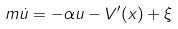Convert formula to latex. <formula><loc_0><loc_0><loc_500><loc_500>m \dot { u } = - \alpha u - V ^ { \prime } ( x ) + \xi</formula> 